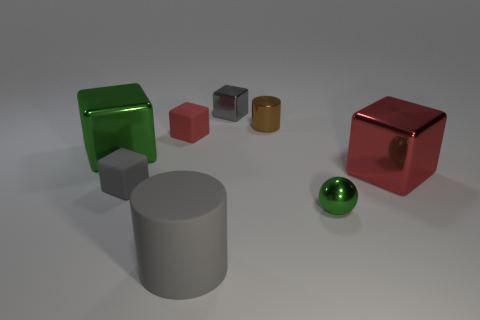There is another block that is the same color as the tiny shiny block; what material is it?
Your answer should be compact. Rubber. What number of small green objects are the same shape as the red shiny thing?
Give a very brief answer. 0. Is the material of the tiny brown cylinder the same as the cylinder on the left side of the brown object?
Provide a short and direct response. No. There is a brown thing that is the same size as the red rubber object; what is it made of?
Provide a succinct answer. Metal. Is there a purple rubber block that has the same size as the sphere?
Offer a very short reply. No. There is a gray matte object that is the same size as the red shiny thing; what is its shape?
Offer a very short reply. Cylinder. What number of other objects are the same color as the tiny shiny block?
Your answer should be compact. 2. The large thing that is on the left side of the tiny green sphere and behind the tiny green ball has what shape?
Give a very brief answer. Cube. Are there any tiny cubes that are left of the red object behind the large cube on the right side of the small green metallic thing?
Your answer should be compact. Yes. How many other objects are there of the same material as the small cylinder?
Offer a terse response. 4. 